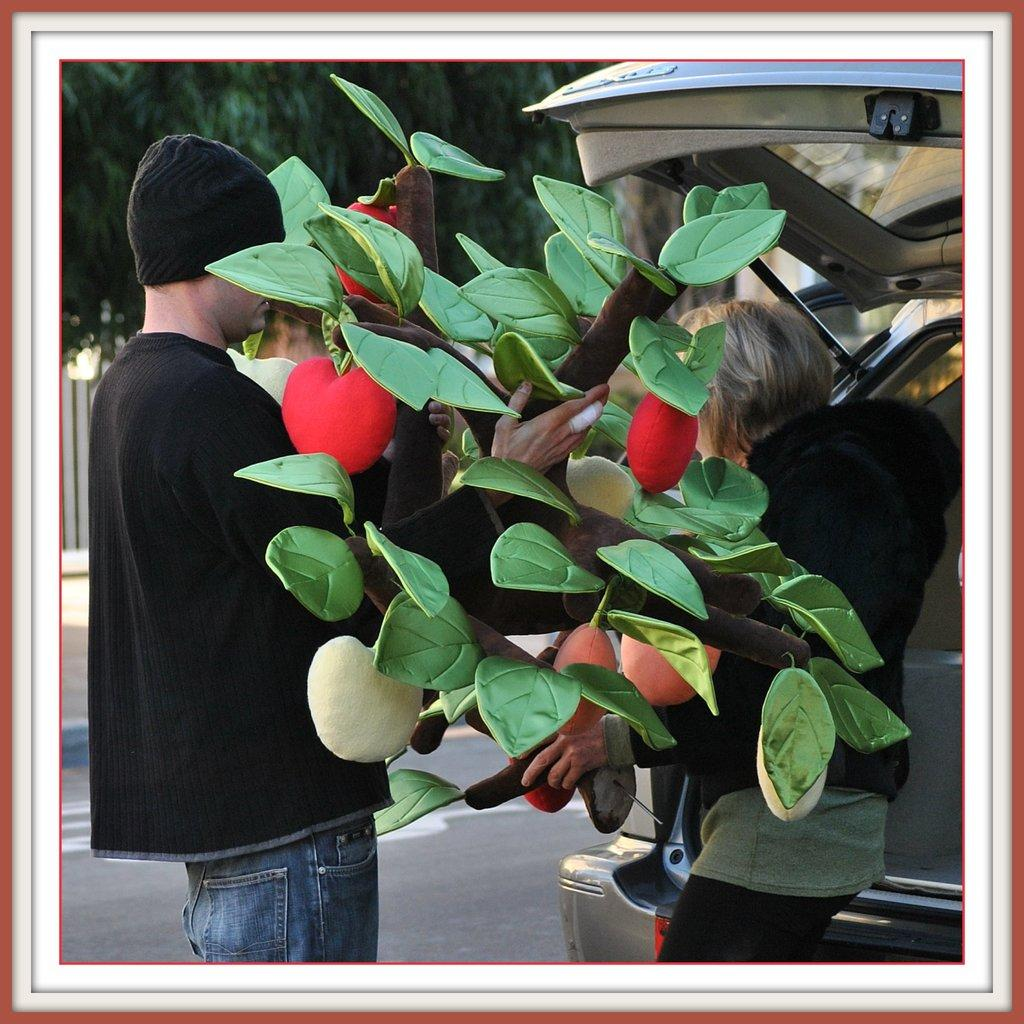How many people are in the image? There are two people in the image, a man and a woman. What are the man and woman doing in the image? The man and woman are standing on the ground and holding a flower vase. What other objects or structures can be seen in the image? There is a car, a fence, and a tree in the image. What type of fish can be seen swimming in the caption of the image? There is no fish or caption present in the image; it only features a man, a woman, a flower vase, a car, a fence, and a tree. 